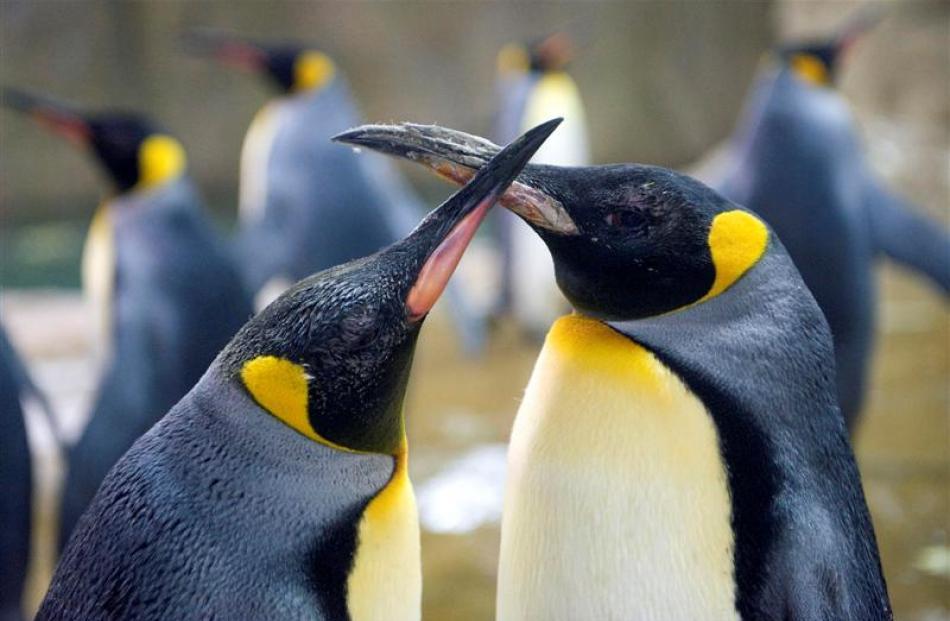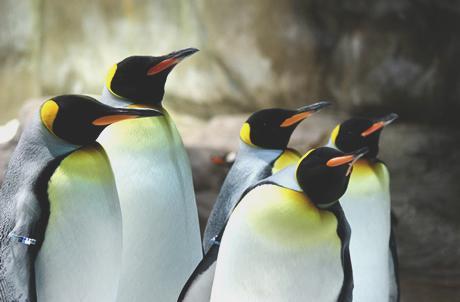The first image is the image on the left, the second image is the image on the right. Examine the images to the left and right. Is the description "There are two penguins with crossed beaks in at least one of the images." accurate? Answer yes or no. Yes. 